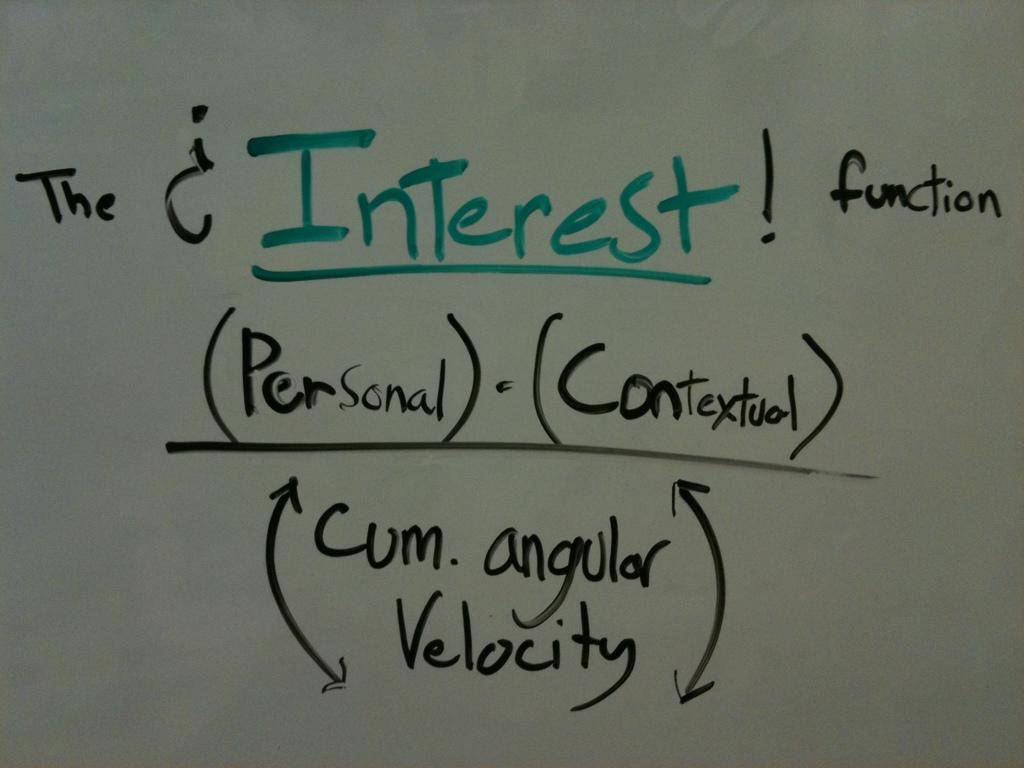What function does the formula represent?
Your answer should be very brief. Interest. What is the fucntion below the divider?
Provide a short and direct response. Cum.angular velocity. 